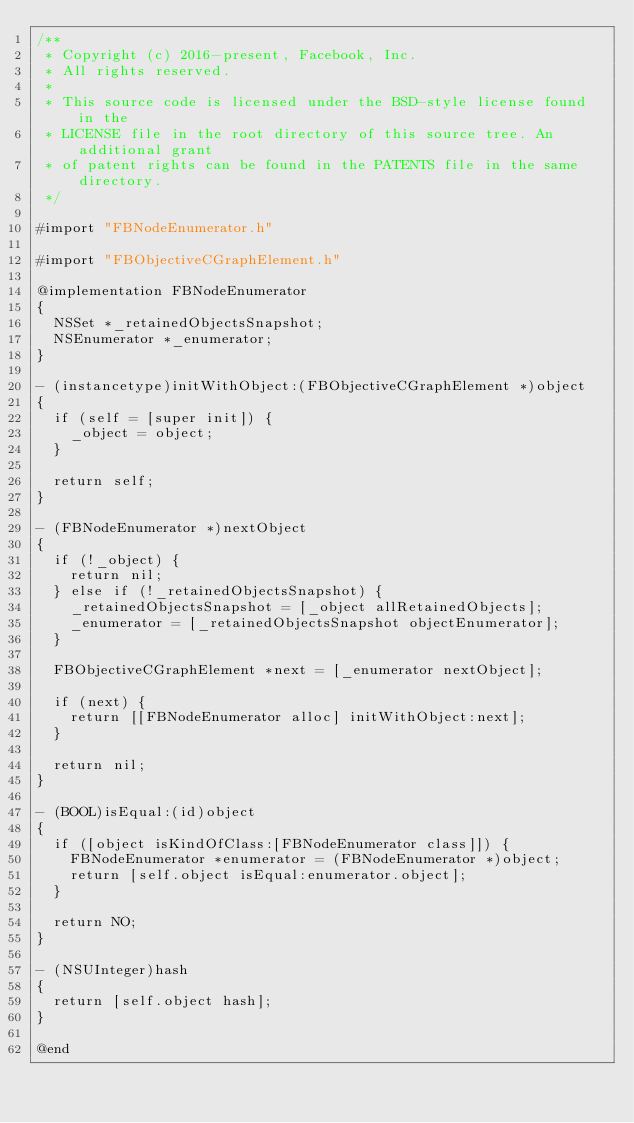<code> <loc_0><loc_0><loc_500><loc_500><_ObjectiveC_>/**
 * Copyright (c) 2016-present, Facebook, Inc.
 * All rights reserved.
 *
 * This source code is licensed under the BSD-style license found in the
 * LICENSE file in the root directory of this source tree. An additional grant
 * of patent rights can be found in the PATENTS file in the same directory.
 */

#import "FBNodeEnumerator.h"

#import "FBObjectiveCGraphElement.h"

@implementation FBNodeEnumerator
{
  NSSet *_retainedObjectsSnapshot;
  NSEnumerator *_enumerator;
}

- (instancetype)initWithObject:(FBObjectiveCGraphElement *)object
{
  if (self = [super init]) {
    _object = object;
  }

  return self;
}

- (FBNodeEnumerator *)nextObject
{
  if (!_object) {
    return nil;
  } else if (!_retainedObjectsSnapshot) {
    _retainedObjectsSnapshot = [_object allRetainedObjects];
    _enumerator = [_retainedObjectsSnapshot objectEnumerator];
  }

  FBObjectiveCGraphElement *next = [_enumerator nextObject];

  if (next) {
    return [[FBNodeEnumerator alloc] initWithObject:next];
  }

  return nil;
}

- (BOOL)isEqual:(id)object
{
  if ([object isKindOfClass:[FBNodeEnumerator class]]) {
    FBNodeEnumerator *enumerator = (FBNodeEnumerator *)object;
    return [self.object isEqual:enumerator.object];
  }

  return NO;
}

- (NSUInteger)hash
{
  return [self.object hash];
}

@end
</code> 